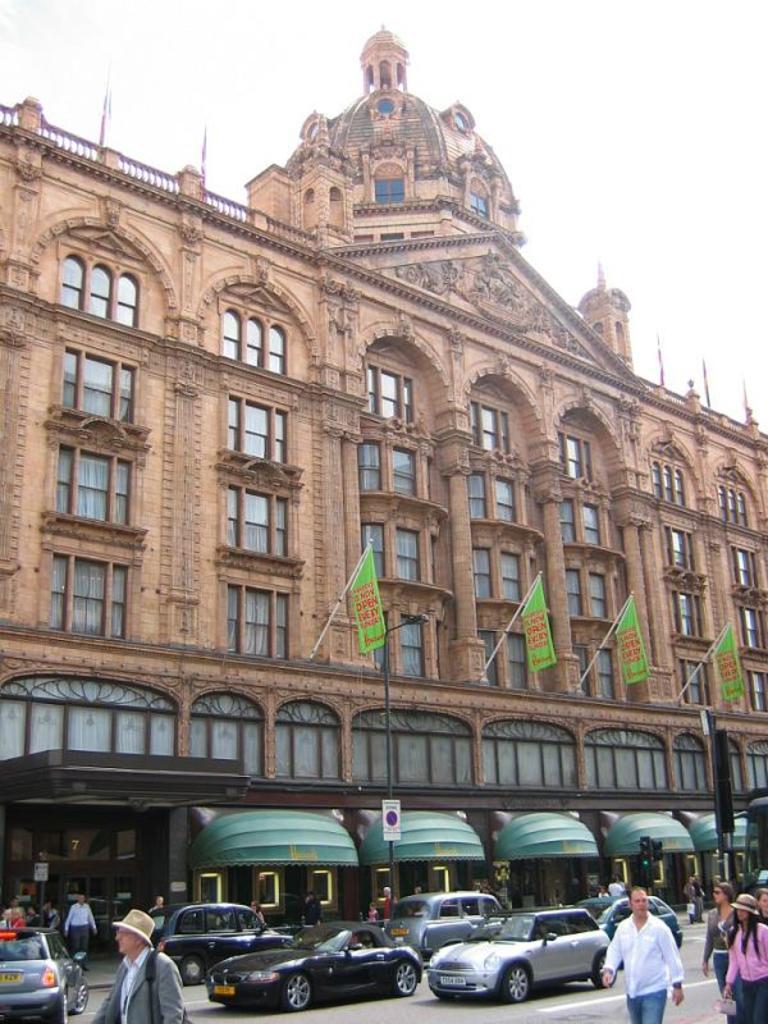Describe this image in one or two sentences. In this picture we can see cars and some people walking on the road, building with windows, signboard, flags, traffic signal light and in the background we can see the sky. 